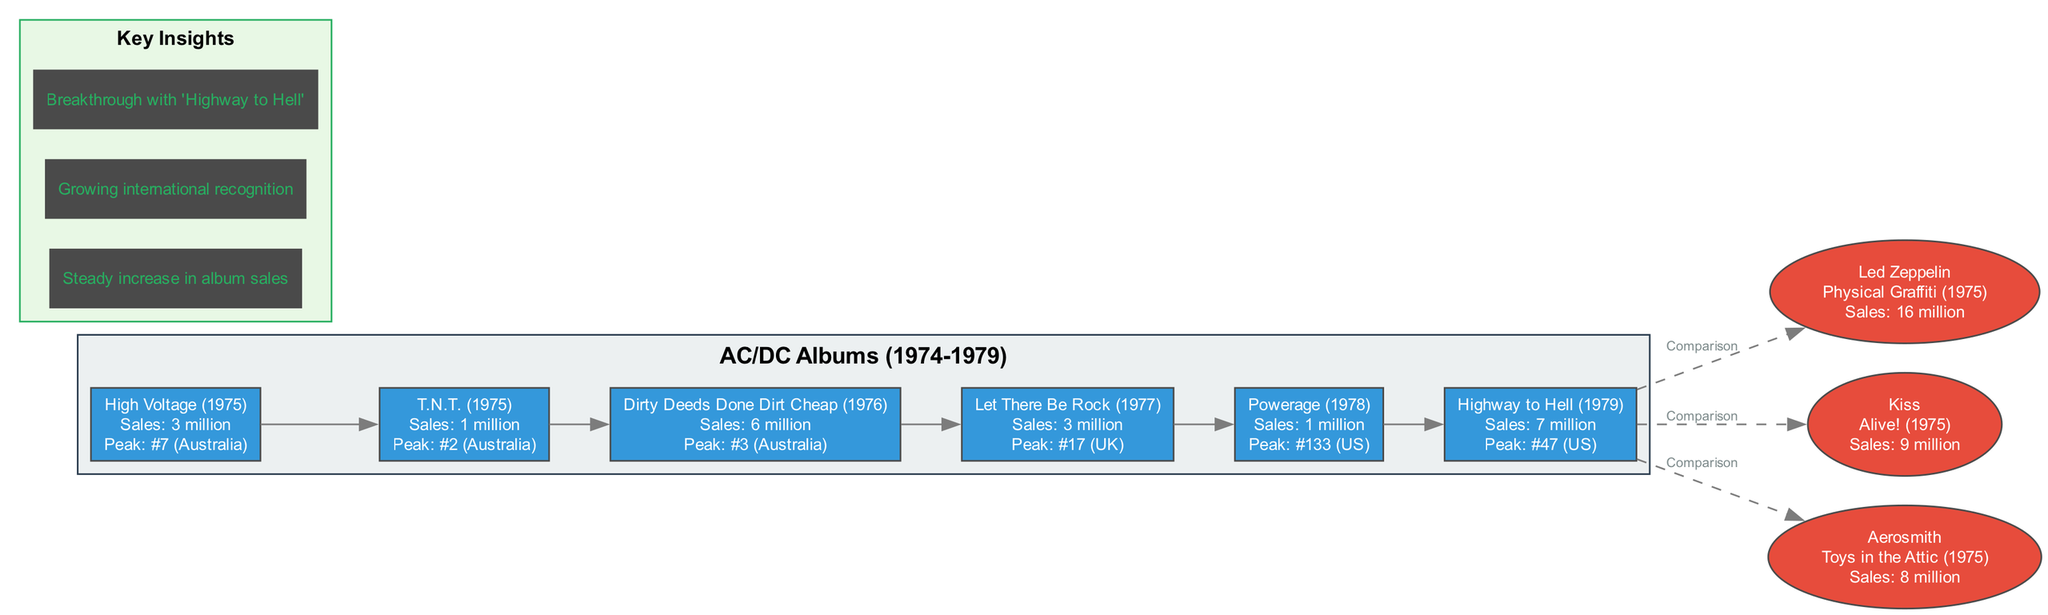What is the sales figure for the album "Highway to Hell"? The sales figure for "Highway to Hell" is listed directly in the diagram as "7 million".
Answer: 7 million What was the peak chart position of "Dirty Deeds Done Dirt Cheap" in Australia? The diagram specifies that "Dirty Deeds Done Dirt Cheap" reached a peak chart position of "#3" in Australia, which is shown in its album details.
Answer: #3 (Australia) How many albums did AC/DC release between 1974 and 1979? Counting the nodes in the AC/DC album subgraph, there are six albums displayed from 1974 to 1979.
Answer: 6 Which album had the highest sales among the comparisons with other bands? The diagram indicates that "Physical Graffiti" by Led Zeppelin had the highest sales figure of "16 million", making it the standout compared to other bands.
Answer: 16 million What is the total sales figure for AC/DC's albums listed in the diagram? To find this, add the sales figures: 3 million + 1 million + 6 million + 3 million + 1 million + 7 million = 21 million total sales for AC/DC.
Answer: 21 million Which AC/DC album marked a significant breakthrough in their career? The insights section of the diagram highlights "Highway to Hell" as the breakthrough album, indicating its importance in the band's success.
Answer: Highway to Hell What is the total sales figure for the album "T.N.T."? The diagram specifies that the sales figure for "T.N.T." is "1 million", which is clearly mentioned in the album details.
Answer: 1 million What kind of relationship is depicted between AC/DC's last album and the comparison bands? The diagram shows a dashed line linking "Highway to Hell" to the comparison bands, indicating a comparison relationship rather than a direct connection.
Answer: Comparison Which band sold more albums than AC/DC during Bon Scott's tenure? Upon examining the comparison section, "Led Zeppelin" is the band that sold 16 million, which is more than any sales from AC/DC's albums during this time.
Answer: Led Zeppelin 